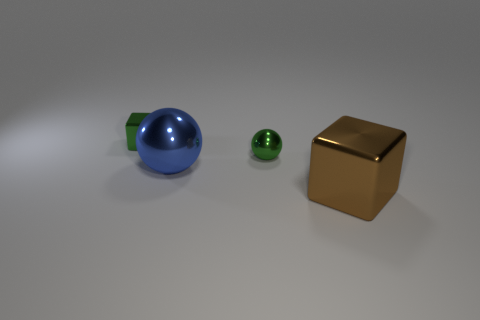Add 2 small yellow rubber things. How many objects exist? 6 Subtract 0 cyan balls. How many objects are left? 4 Subtract all balls. Subtract all brown things. How many objects are left? 1 Add 1 green metal things. How many green metal things are left? 3 Add 2 tiny cubes. How many tiny cubes exist? 3 